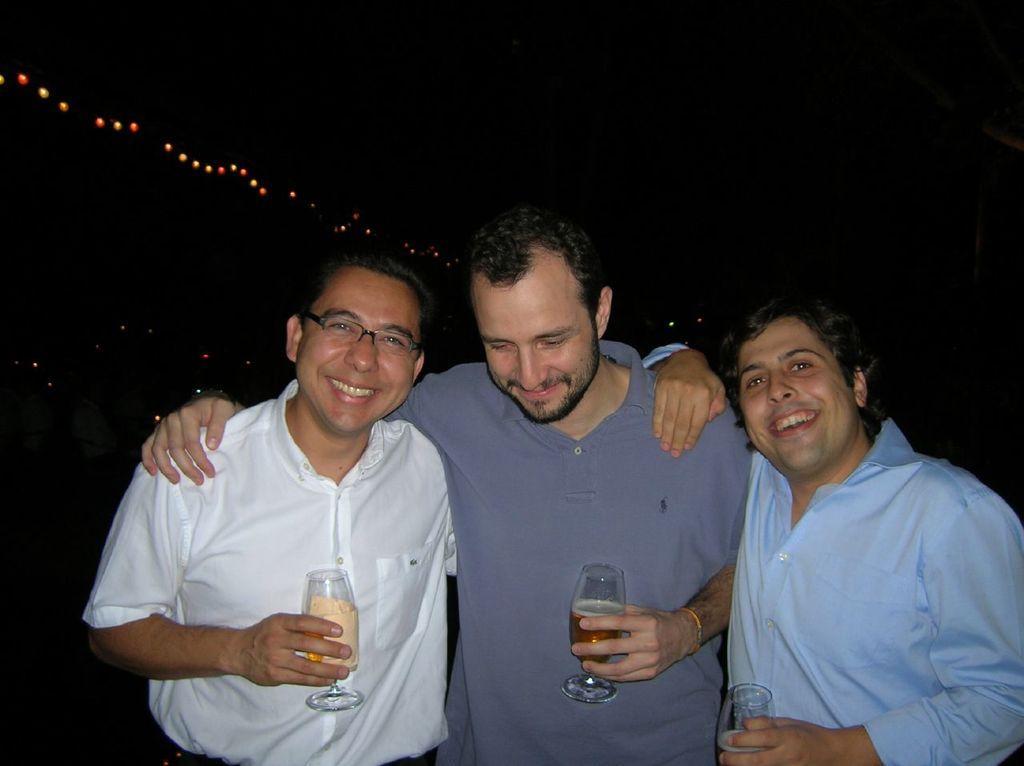Could you give a brief overview of what you see in this image? There are three men standing and holding glasses and smiling. In the background it is dark and we can see lights. 